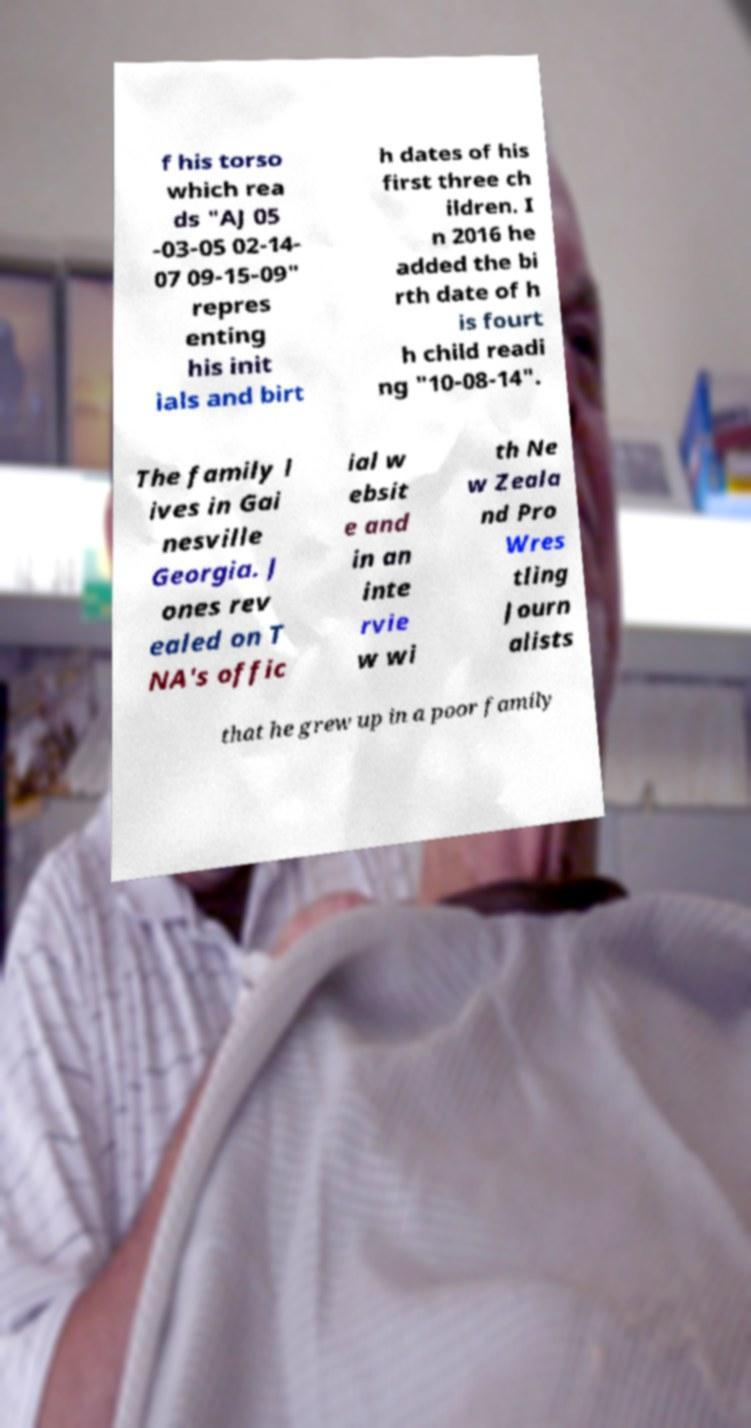Can you read and provide the text displayed in the image?This photo seems to have some interesting text. Can you extract and type it out for me? f his torso which rea ds "AJ 05 -03-05 02-14- 07 09-15-09" repres enting his init ials and birt h dates of his first three ch ildren. I n 2016 he added the bi rth date of h is fourt h child readi ng "10-08-14". The family l ives in Gai nesville Georgia. J ones rev ealed on T NA's offic ial w ebsit e and in an inte rvie w wi th Ne w Zeala nd Pro Wres tling Journ alists that he grew up in a poor family 